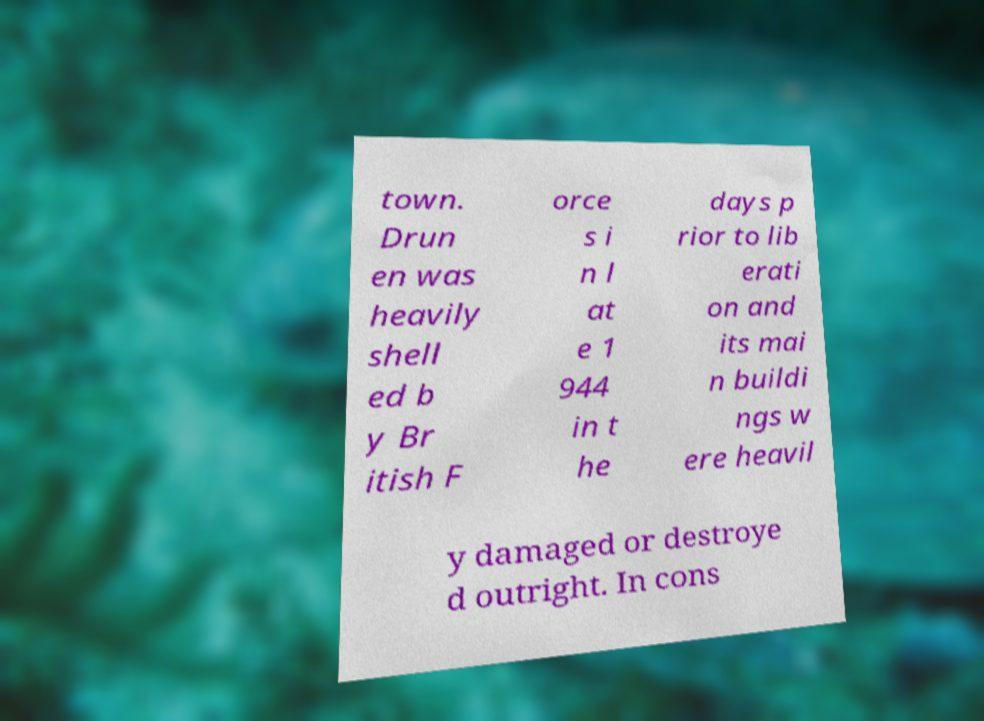Could you extract and type out the text from this image? town. Drun en was heavily shell ed b y Br itish F orce s i n l at e 1 944 in t he days p rior to lib erati on and its mai n buildi ngs w ere heavil y damaged or destroye d outright. In cons 